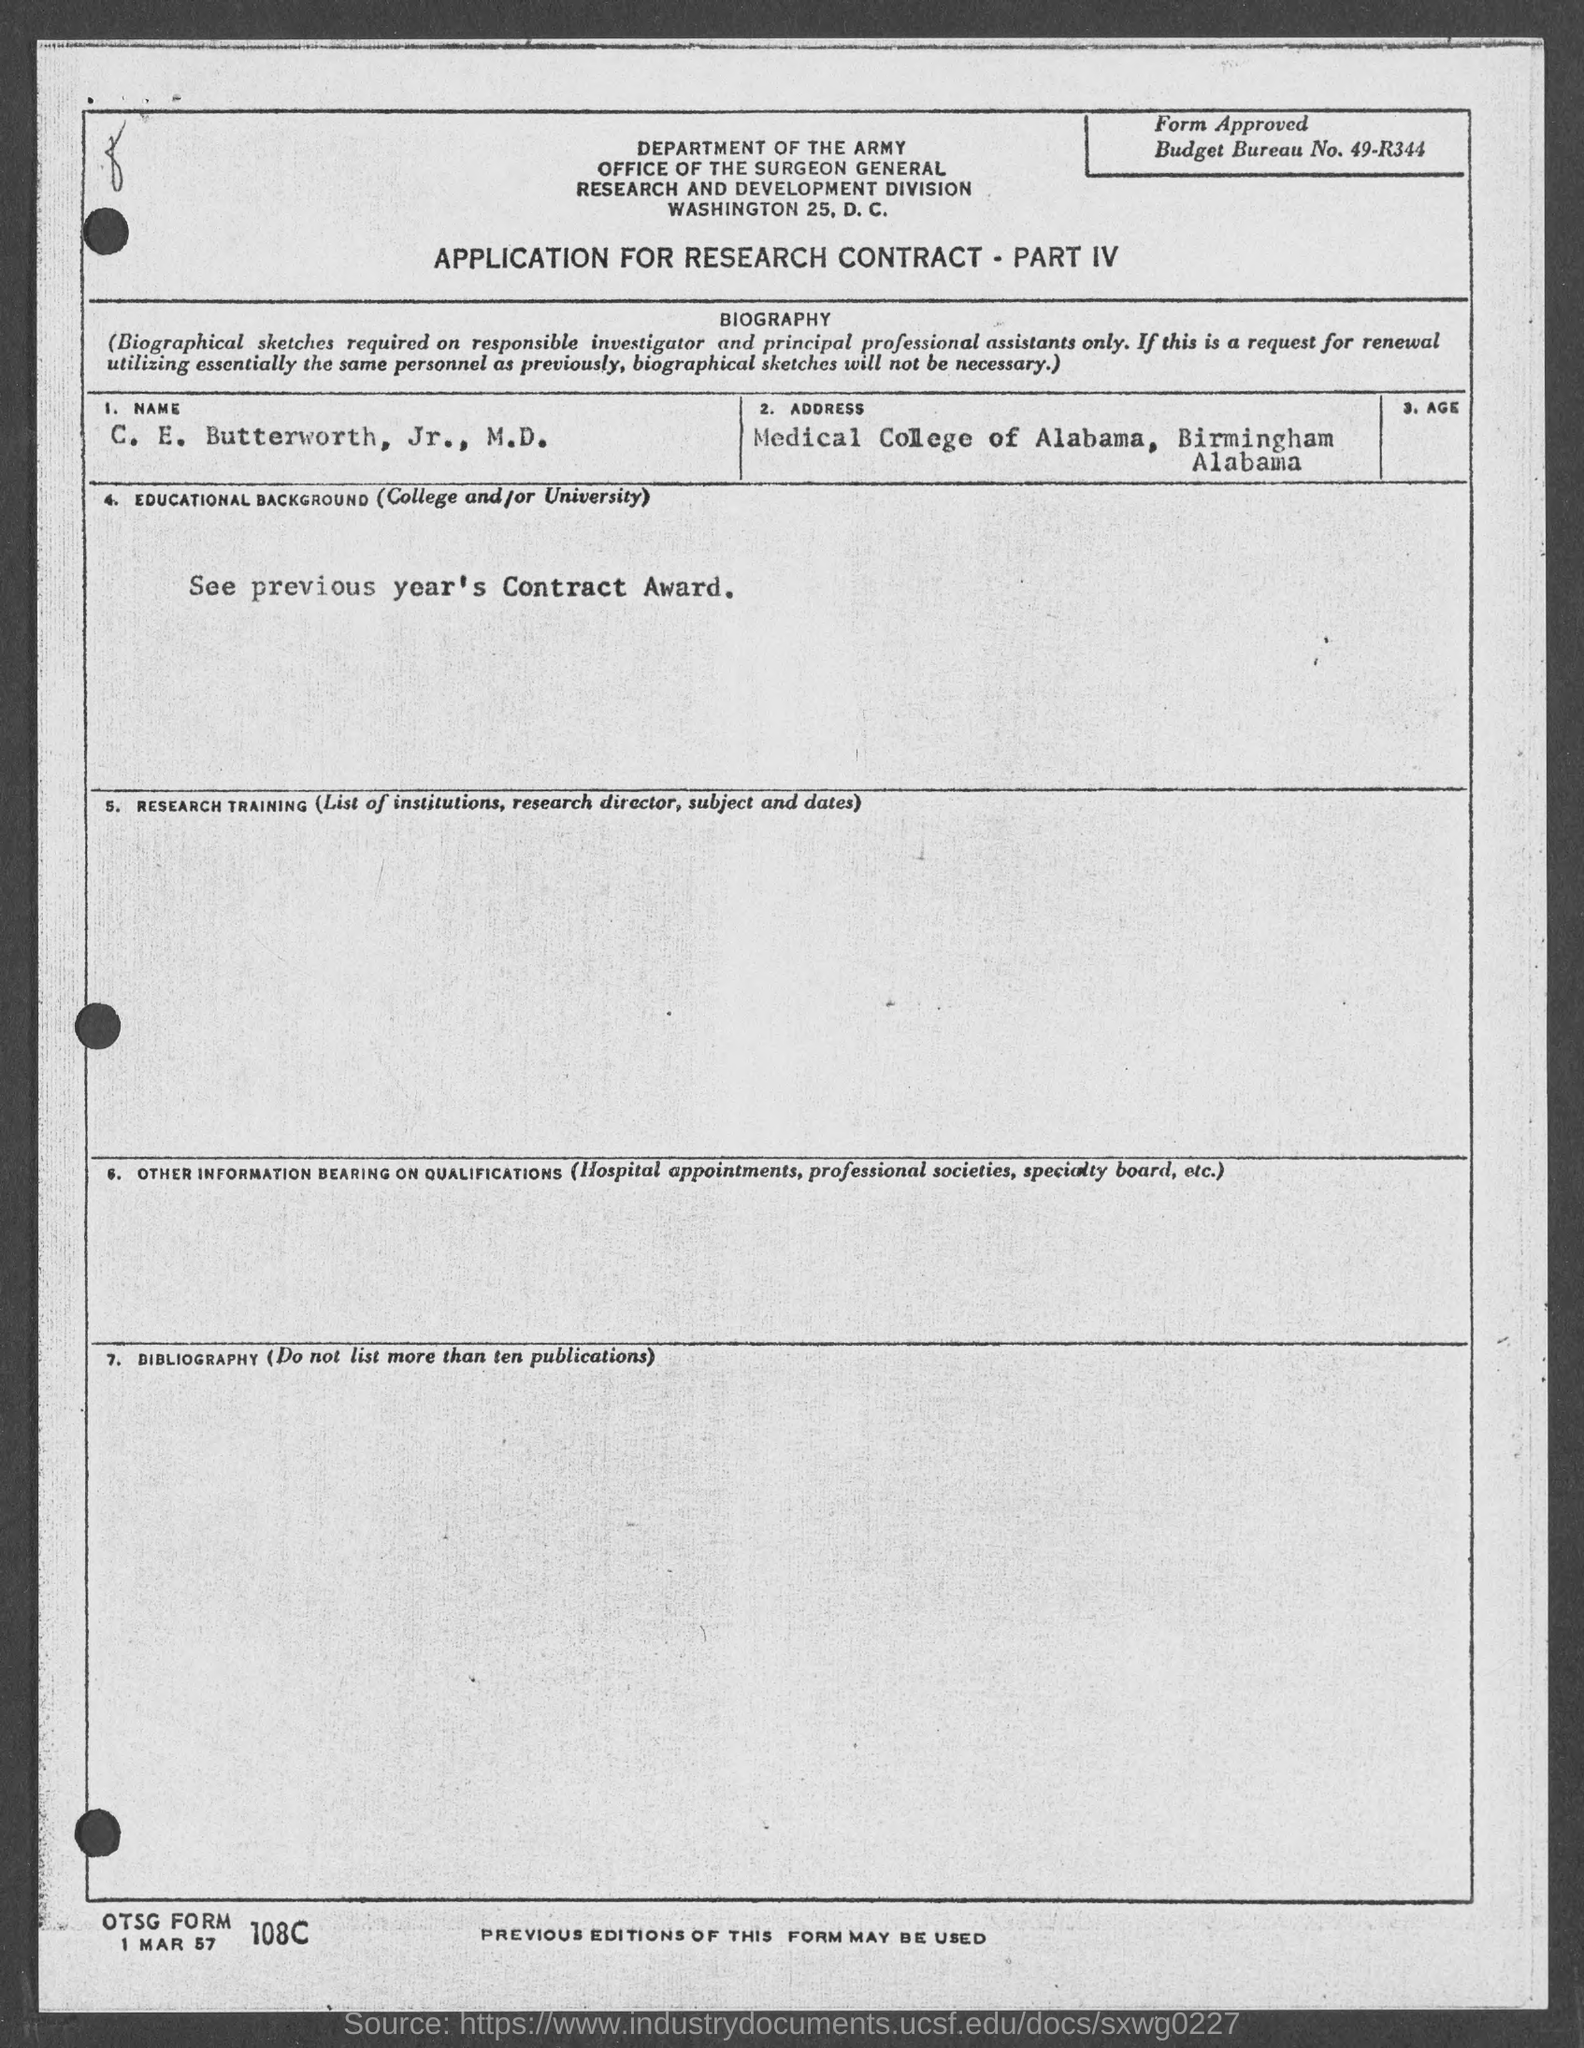Outline some significant characteristics in this image. What is the budget bureau number? 49-r344..." is a question that seeks information about a budget bureau number. The name of the person in the form is Dr. C.E. Butterworth, Jr. The Medical College of Alabama is located in Birmingham. 